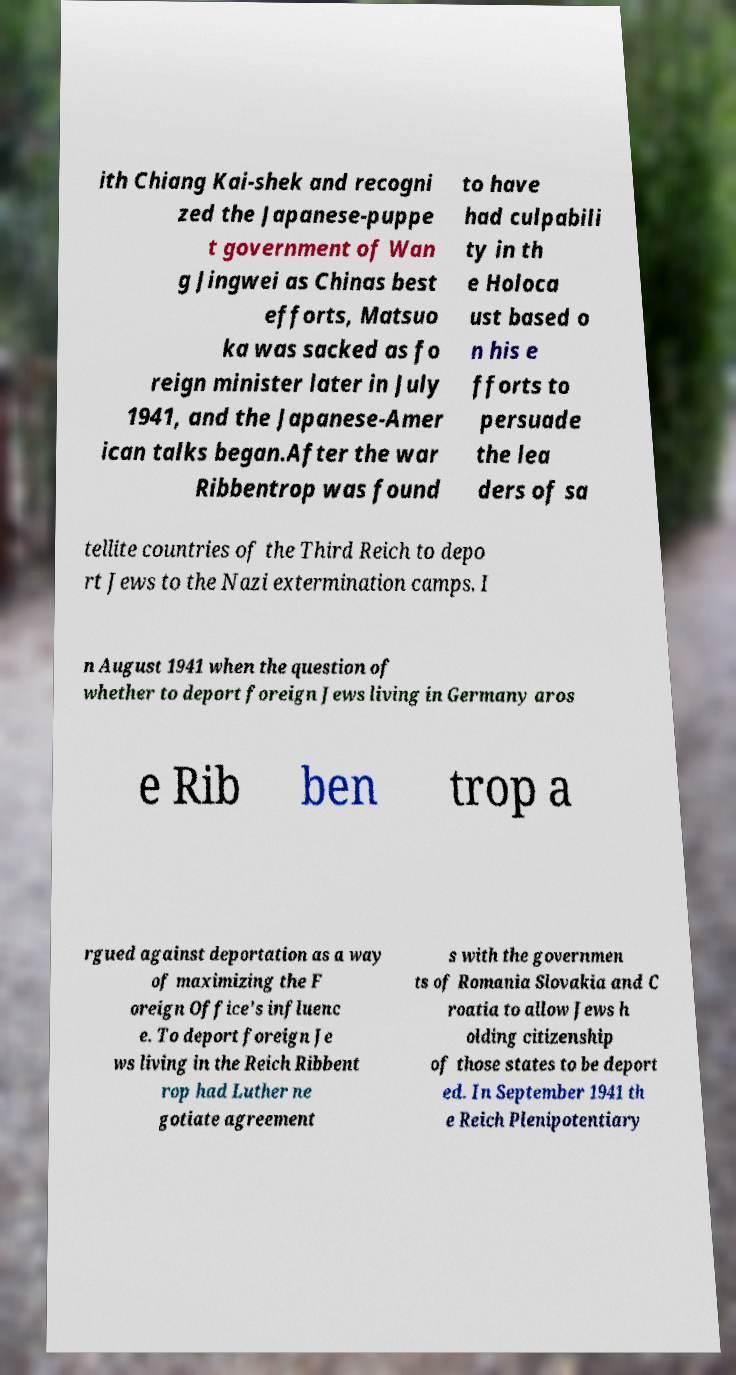For documentation purposes, I need the text within this image transcribed. Could you provide that? ith Chiang Kai-shek and recogni zed the Japanese-puppe t government of Wan g Jingwei as Chinas best efforts, Matsuo ka was sacked as fo reign minister later in July 1941, and the Japanese-Amer ican talks began.After the war Ribbentrop was found to have had culpabili ty in th e Holoca ust based o n his e fforts to persuade the lea ders of sa tellite countries of the Third Reich to depo rt Jews to the Nazi extermination camps. I n August 1941 when the question of whether to deport foreign Jews living in Germany aros e Rib ben trop a rgued against deportation as a way of maximizing the F oreign Office's influenc e. To deport foreign Je ws living in the Reich Ribbent rop had Luther ne gotiate agreement s with the governmen ts of Romania Slovakia and C roatia to allow Jews h olding citizenship of those states to be deport ed. In September 1941 th e Reich Plenipotentiary 